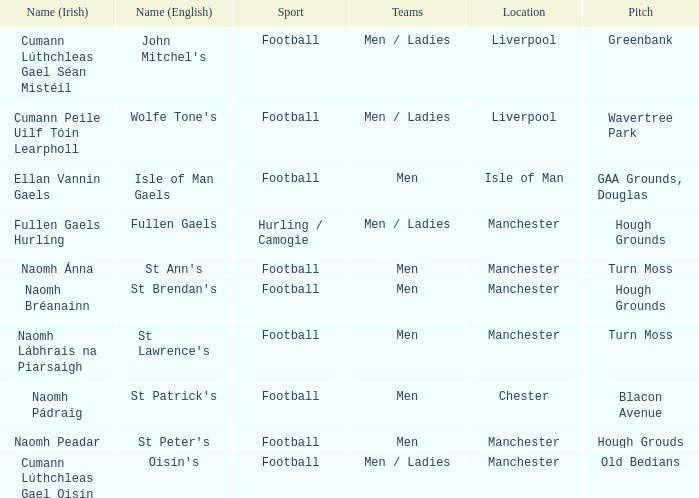What Pitch is located at Isle of Man? GAA Grounds, Douglas. 